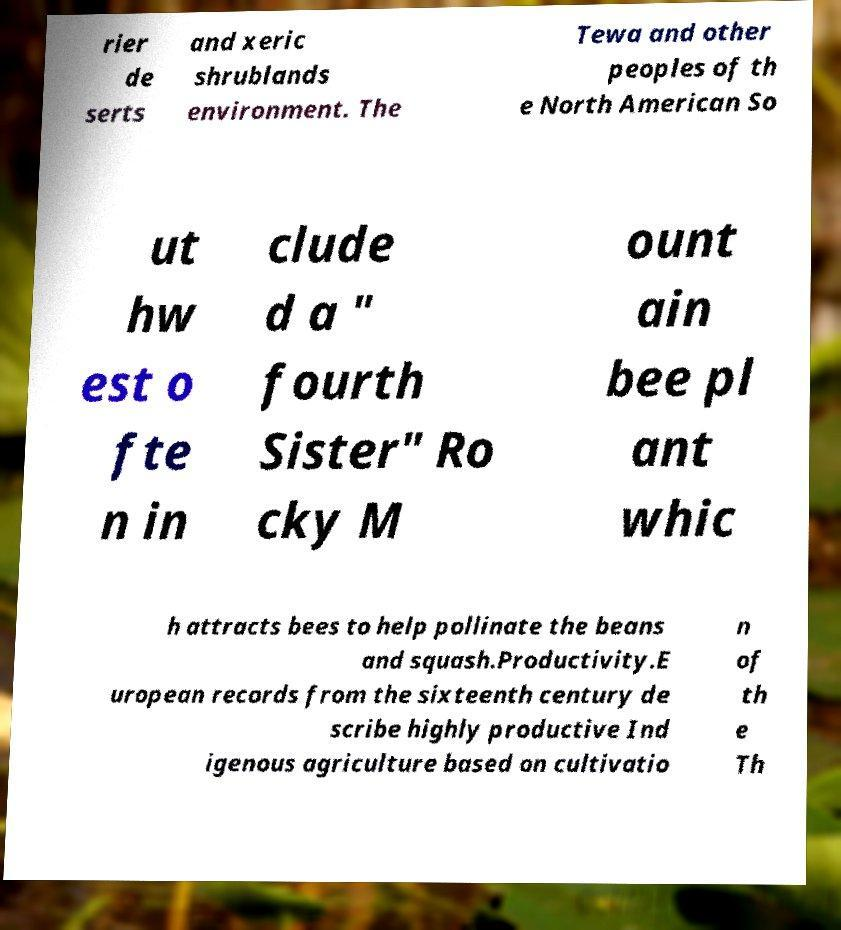Can you read and provide the text displayed in the image?This photo seems to have some interesting text. Can you extract and type it out for me? rier de serts and xeric shrublands environment. The Tewa and other peoples of th e North American So ut hw est o fte n in clude d a " fourth Sister" Ro cky M ount ain bee pl ant whic h attracts bees to help pollinate the beans and squash.Productivity.E uropean records from the sixteenth century de scribe highly productive Ind igenous agriculture based on cultivatio n of th e Th 